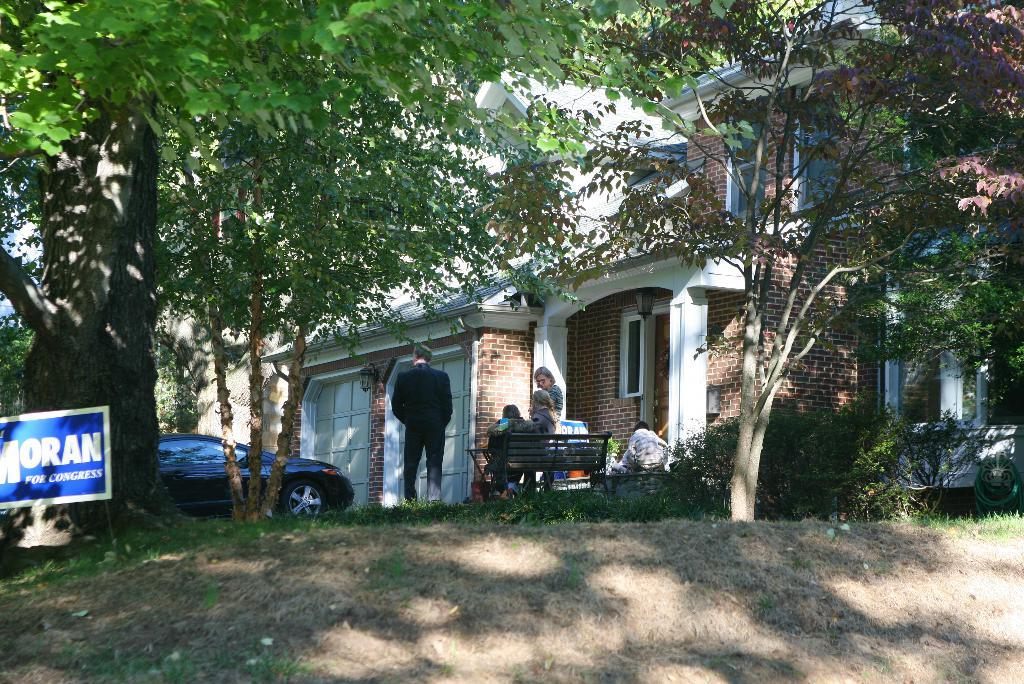What type of structure is present in the image? There is a building in the image. What are the two persons on the bench doing? The two persons are sitting on a bench. Can you describe the people standing in the image? There are people standing in the image. What mode of transportation can be seen in the image? There is a car in the image. What type of vegetation is visible in the image? There are green trees visible in the image. Is there any paste visible on the car in the image? There is no mention of paste in the provided facts, and therefore it cannot be determined if there is any paste visible on the car in the image. How does the rainstorm affect the people in the image? There is no mention of a rainstorm in the provided facts, so it cannot be determined how it would affect the people in the image. 